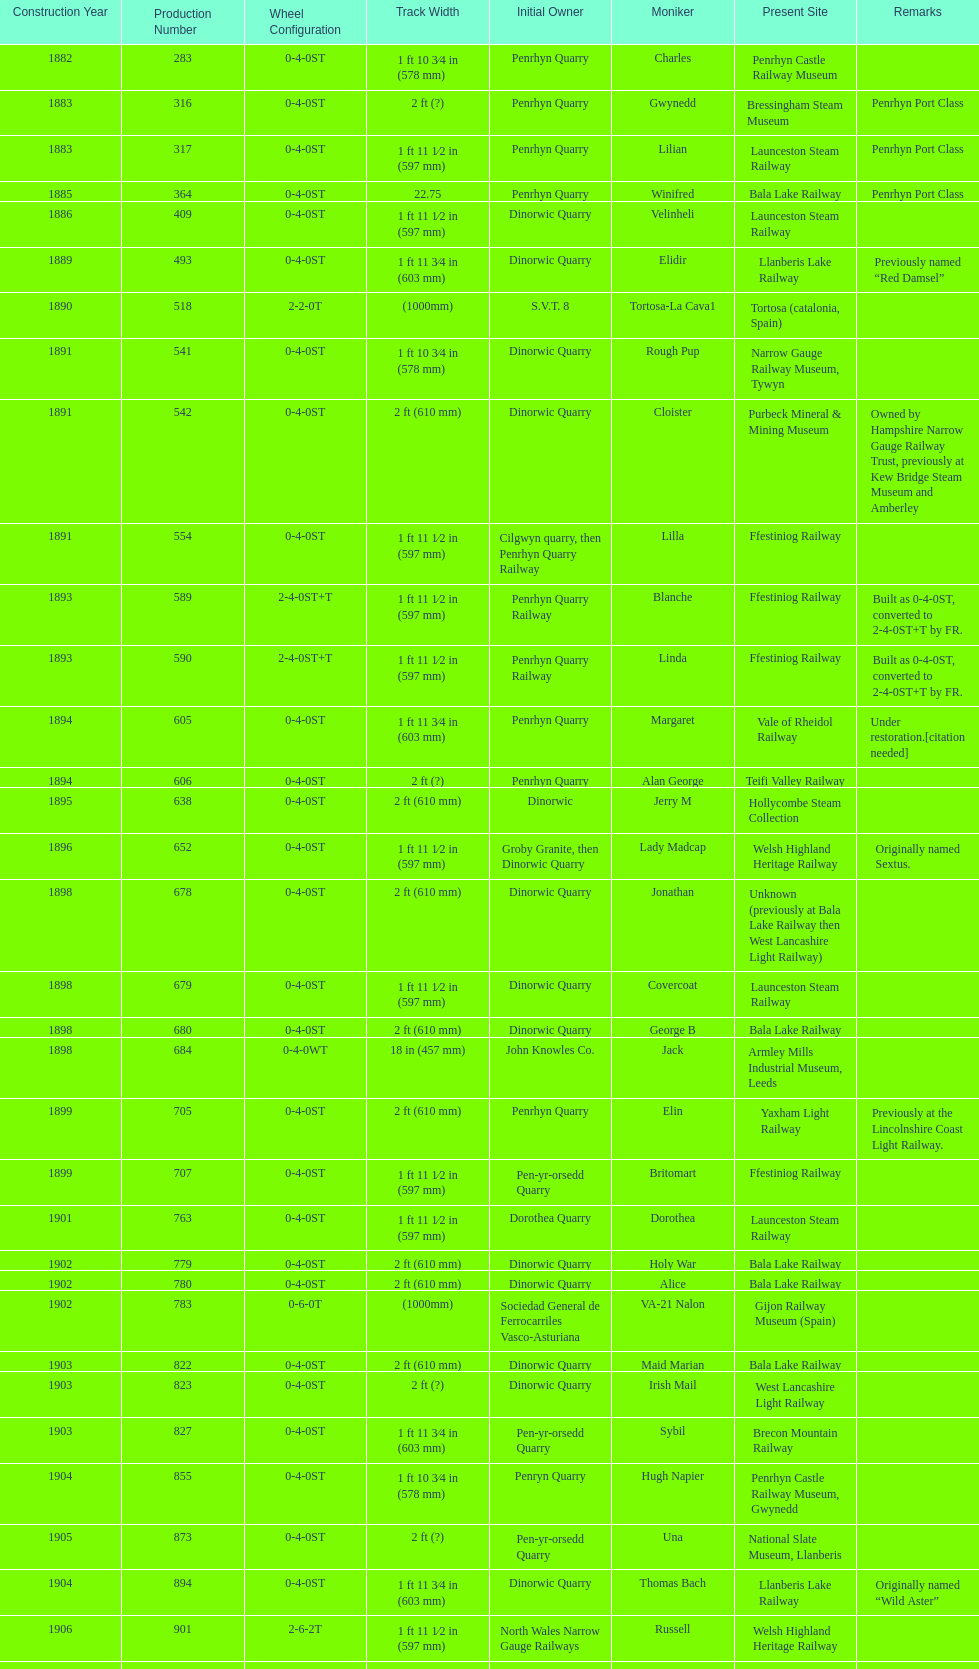What is the total number of preserved hunslet narrow gauge locomotives currently located in ffestiniog railway 554. 